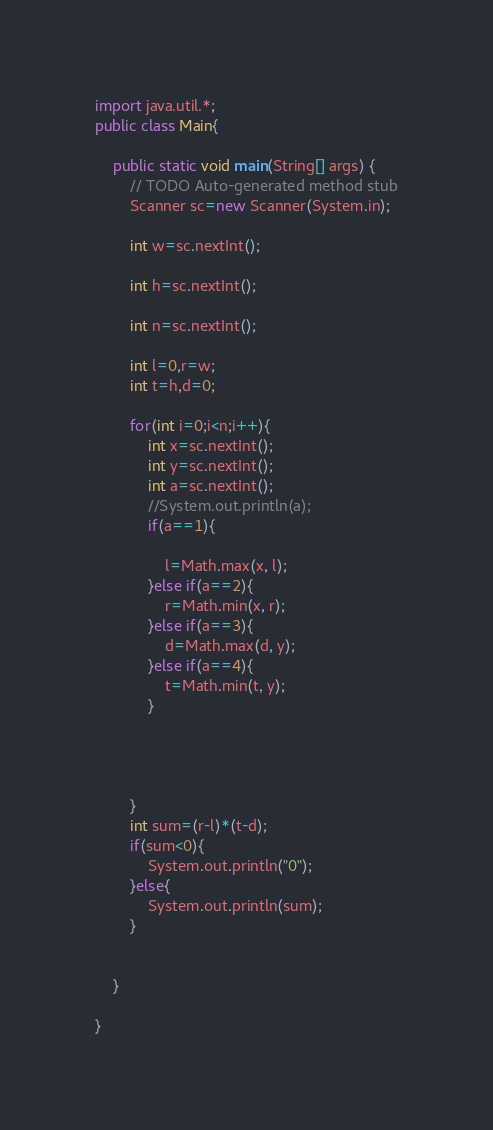<code> <loc_0><loc_0><loc_500><loc_500><_Java_>import java.util.*;
public class Main{

	public static void main(String[] args) {
		// TODO Auto-generated method stub
		Scanner sc=new Scanner(System.in);
		
		int w=sc.nextInt();
		
		int h=sc.nextInt();
		
		int n=sc.nextInt();
		
		int l=0,r=w;
		int t=h,d=0;
		
		for(int i=0;i<n;i++){
			int x=sc.nextInt();
			int y=sc.nextInt();
			int a=sc.nextInt();
			//System.out.println(a);
			if(a==1){
				
				l=Math.max(x, l);
			}else if(a==2){
				r=Math.min(x, r);
			}else if(a==3){
				d=Math.max(d, y);
			}else if(a==4){
				t=Math.min(t, y);
			}
			
			
			
			
		}
		int sum=(r-l)*(t-d);
		if(sum<0){
			System.out.println("0");
		}else{
			System.out.println(sum);
		}
				
		
	}

}
</code> 